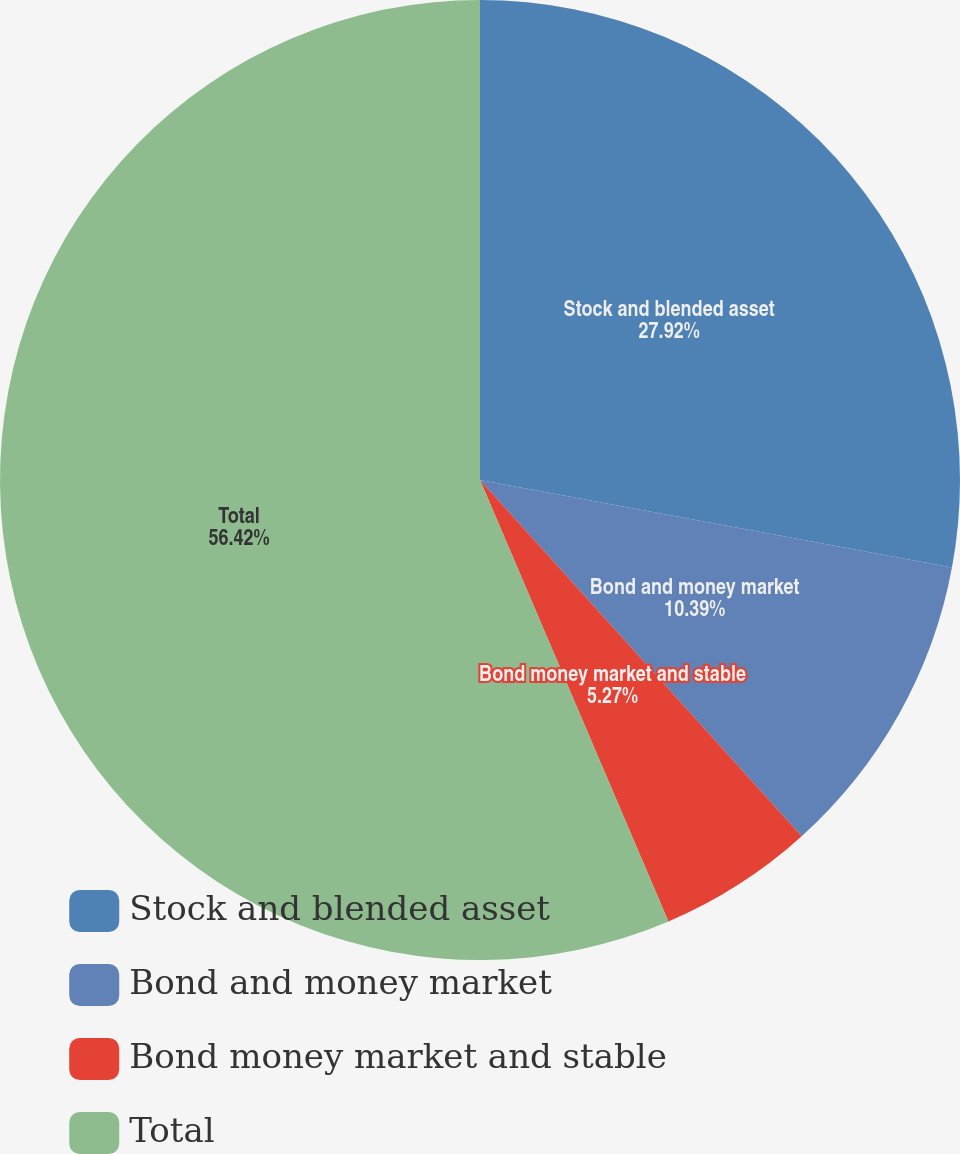Convert chart. <chart><loc_0><loc_0><loc_500><loc_500><pie_chart><fcel>Stock and blended asset<fcel>Bond and money market<fcel>Bond money market and stable<fcel>Total<nl><fcel>27.92%<fcel>10.39%<fcel>5.27%<fcel>56.42%<nl></chart> 